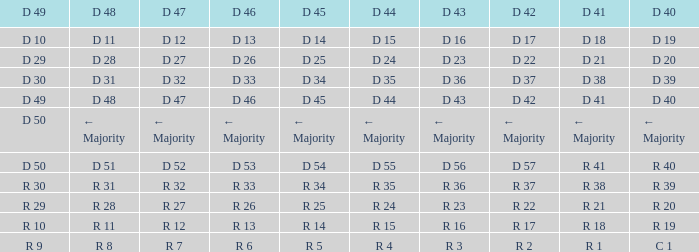I want the D 47 for D 41 being r 21 R 27. 